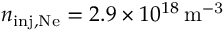Convert formula to latex. <formula><loc_0><loc_0><loc_500><loc_500>n _ { i n j , N e } = 2 . 9 \times 1 0 ^ { 1 8 } \, m ^ { - 3 }</formula> 